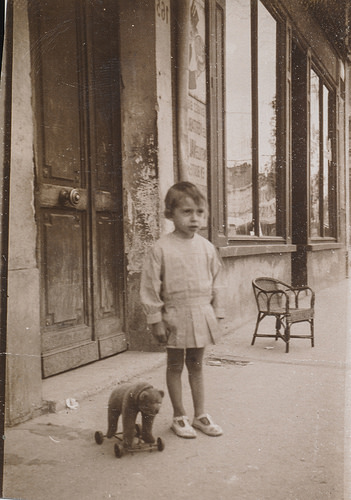<image>
Is there a building behind the child? Yes. From this viewpoint, the building is positioned behind the child, with the child partially or fully occluding the building. Where is the toy in relation to the child? Is it to the left of the child? Yes. From this viewpoint, the toy is positioned to the left side relative to the child. 